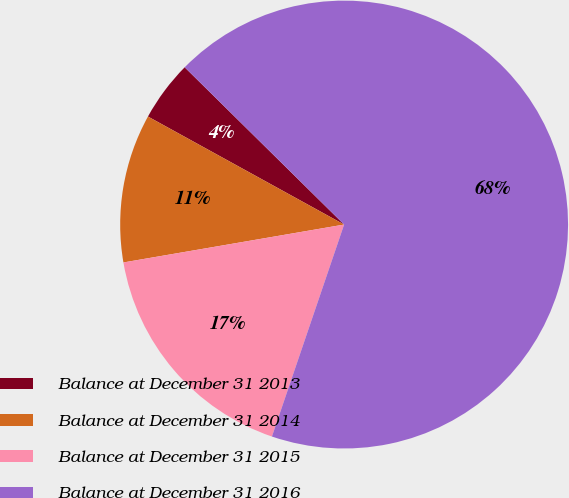Convert chart. <chart><loc_0><loc_0><loc_500><loc_500><pie_chart><fcel>Balance at December 31 2013<fcel>Balance at December 31 2014<fcel>Balance at December 31 2015<fcel>Balance at December 31 2016<nl><fcel>4.38%<fcel>10.72%<fcel>17.07%<fcel>67.84%<nl></chart> 